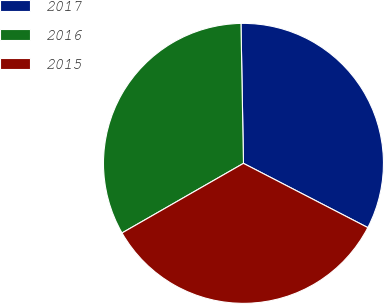<chart> <loc_0><loc_0><loc_500><loc_500><pie_chart><fcel>2017<fcel>2016<fcel>2015<nl><fcel>32.87%<fcel>33.0%<fcel>34.13%<nl></chart> 